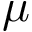<formula> <loc_0><loc_0><loc_500><loc_500>\mu</formula> 